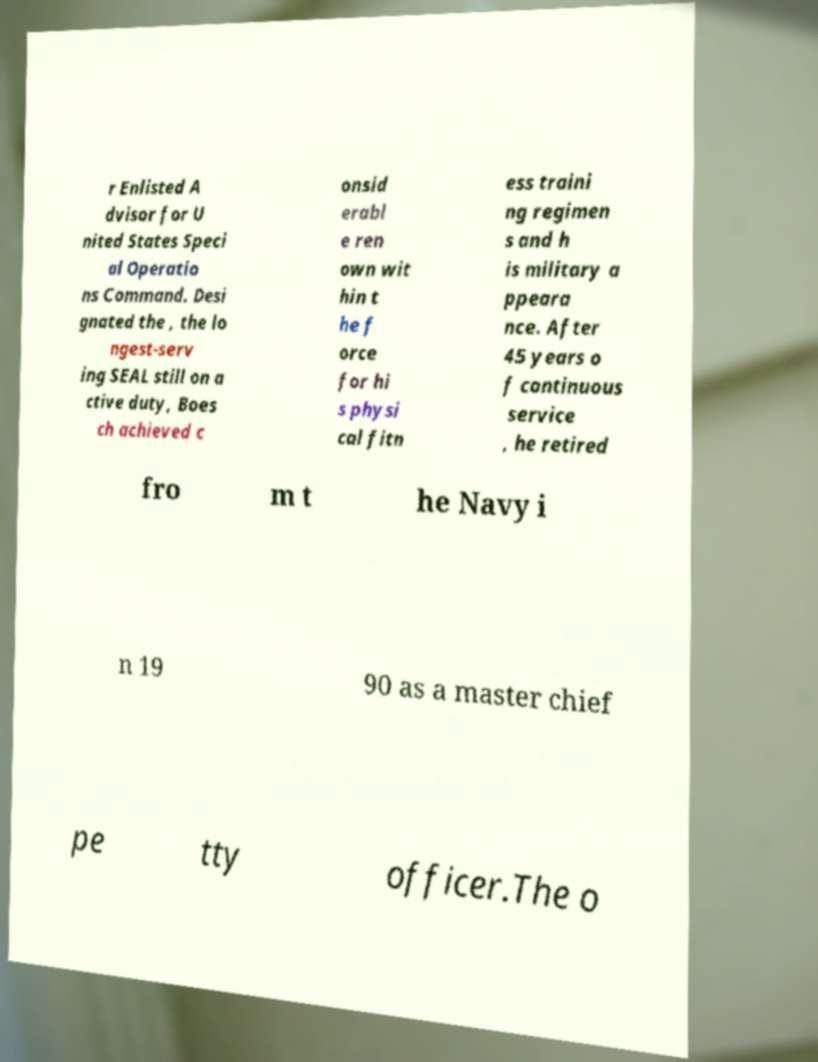What messages or text are displayed in this image? I need them in a readable, typed format. r Enlisted A dvisor for U nited States Speci al Operatio ns Command. Desi gnated the , the lo ngest-serv ing SEAL still on a ctive duty, Boes ch achieved c onsid erabl e ren own wit hin t he f orce for hi s physi cal fitn ess traini ng regimen s and h is military a ppeara nce. After 45 years o f continuous service , he retired fro m t he Navy i n 19 90 as a master chief pe tty officer.The o 